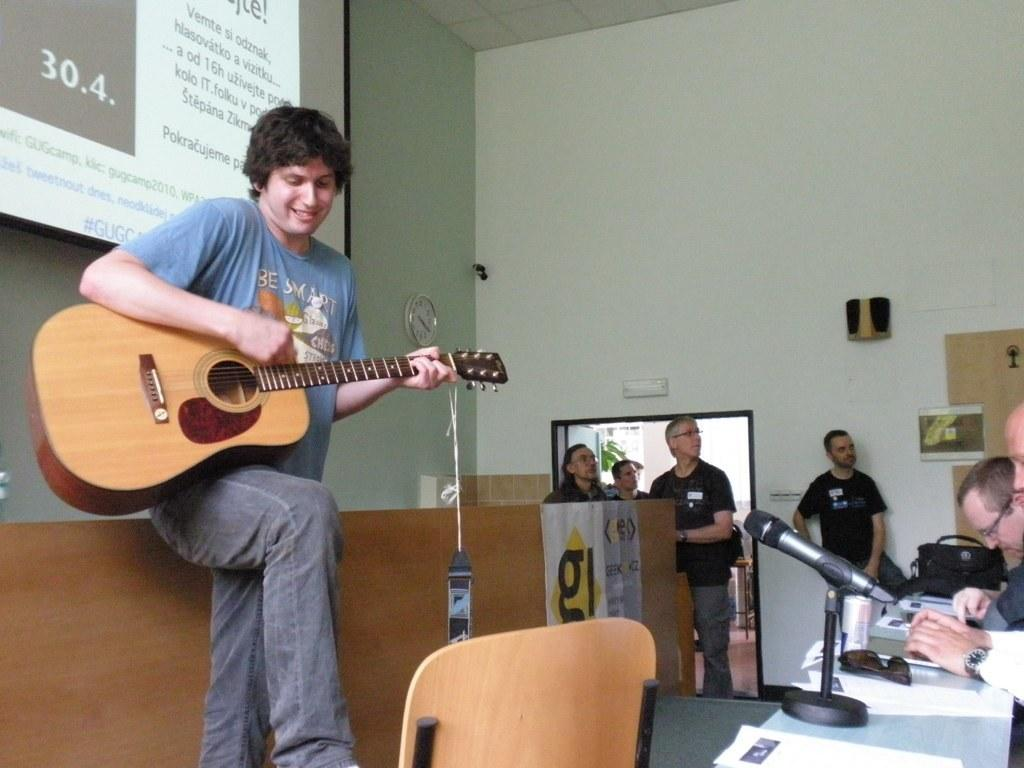What is the color of the wall in the image? The wall in the image is white. What can be seen on the wall in the image? There is a screen on the wall in the image. What is the man in the image holding? The man in the image is holding a guitar. What type of furniture is present in the image? There are tables and chairs in the image. What items can be seen on the tables in the image? There is a microphone and papers on a table in the image. Can you see any clouds in the image? There are no clouds visible in the image, as it is an indoor setting. How many toes does the man have on his left foot in the image? There is no information about the man's toes in the image, as it focuses on the guitar he is holding. 